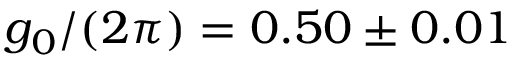Convert formula to latex. <formula><loc_0><loc_0><loc_500><loc_500>g _ { 0 } / ( 2 \pi ) = 0 . 5 0 \pm 0 . 0 1</formula> 